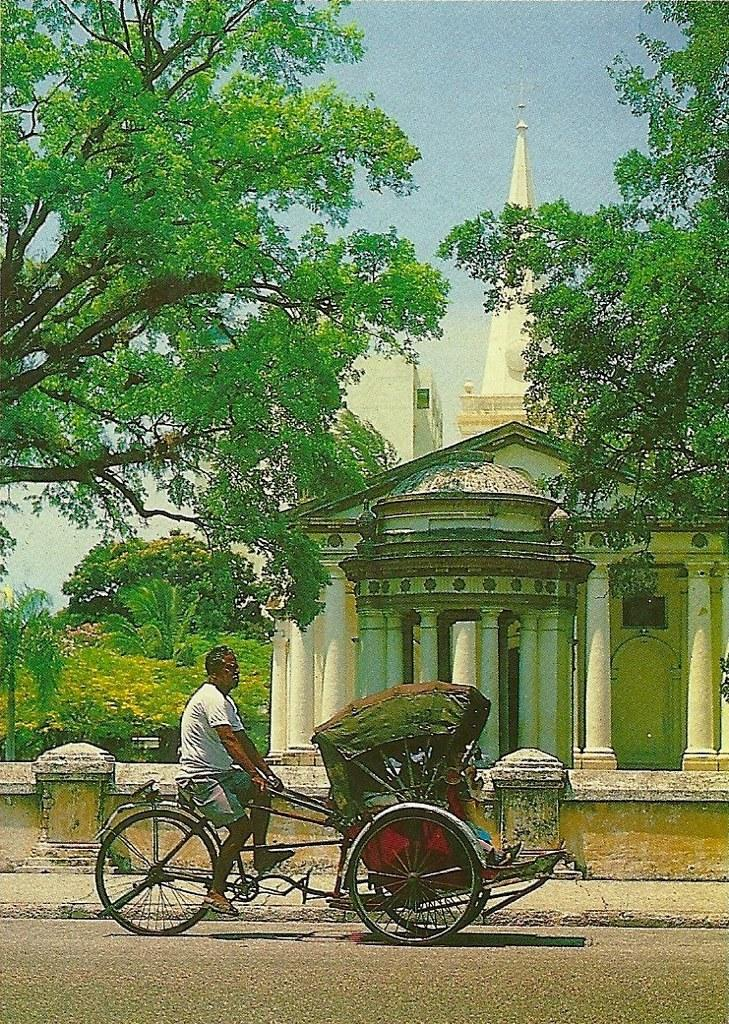What is the main subject of the image? There is a person riding a bicycle in the image. What can be seen near the person? There is a building near the person. What type of natural elements are present in the image? There are trees in the image. What is visible in the background of the image? The sky is visible in the background of the image. What type of riddle can be solved by looking at the angle of the bicycle in the image? There is no riddle present in the image, nor is there any mention of an angle related to the bicycle. 